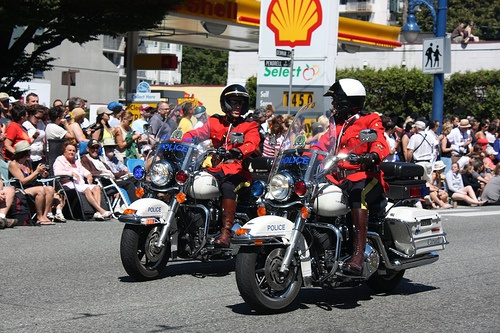Describe the objects in this image and their specific colors. I can see people in black, darkgray, gray, and lightgray tones, motorcycle in black, gray, white, and darkgray tones, motorcycle in black, gray, white, and darkgray tones, people in black, red, maroon, and salmon tones, and people in black, maroon, red, and salmon tones in this image. 